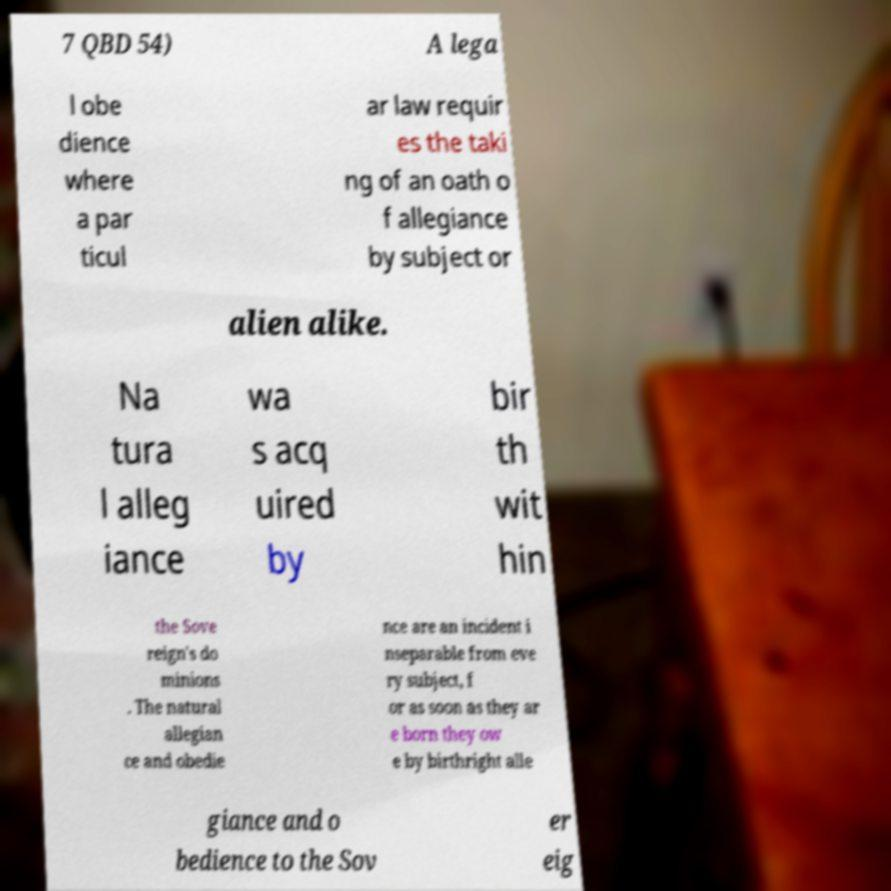Could you assist in decoding the text presented in this image and type it out clearly? 7 QBD 54) A lega l obe dience where a par ticul ar law requir es the taki ng of an oath o f allegiance by subject or alien alike. Na tura l alleg iance wa s acq uired by bir th wit hin the Sove reign's do minions . The natural allegian ce and obedie nce are an incident i nseparable from eve ry subject, f or as soon as they ar e born they ow e by birthright alle giance and o bedience to the Sov er eig 